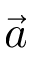<formula> <loc_0><loc_0><loc_500><loc_500>\vec { a }</formula> 